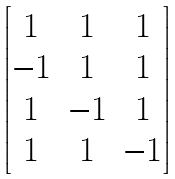<formula> <loc_0><loc_0><loc_500><loc_500>\begin{bmatrix} 1 & 1 & 1 \\ - 1 & 1 & 1 \\ 1 & - 1 & 1 \\ 1 & 1 & - 1 \end{bmatrix}</formula> 